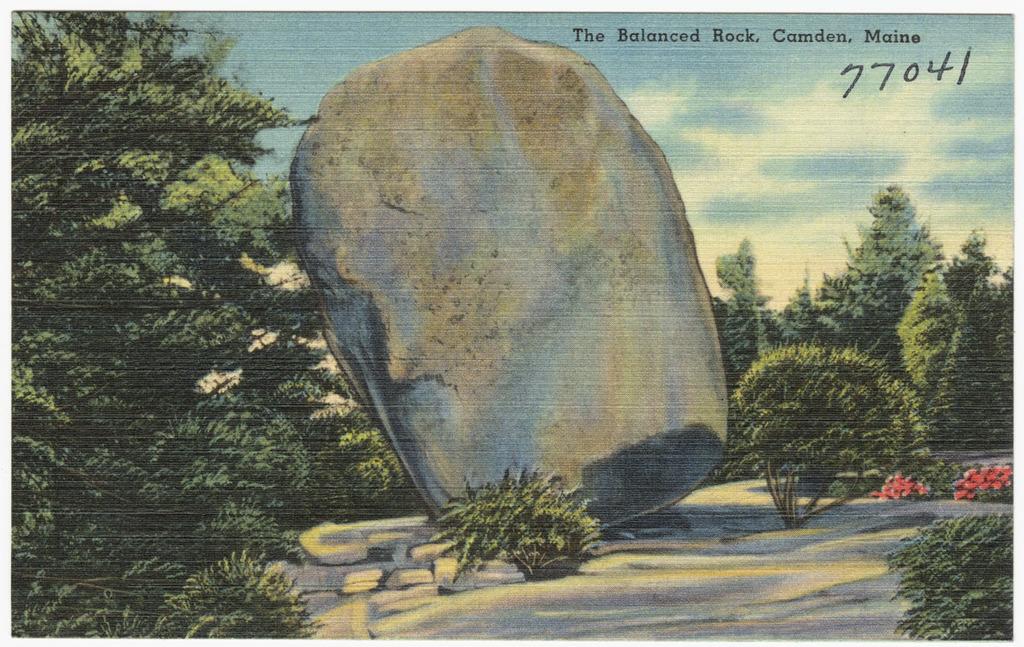What number is written on the postcard?
Give a very brief answer. 77041. Were is this at?
Ensure brevity in your answer.  Camden, maine. 